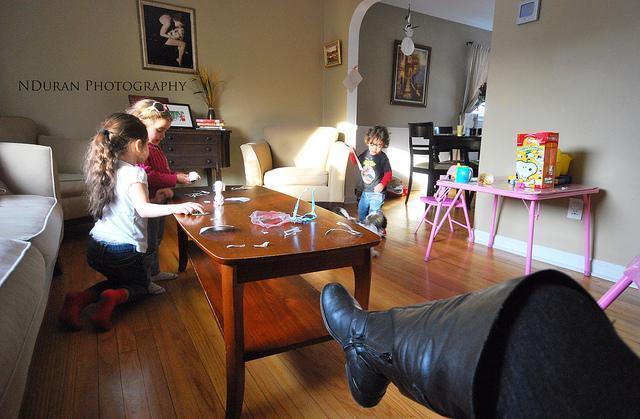How many people in the image are adult?
Give a very brief answer. 1. How many people are there?
Give a very brief answer. 4. How many chairs are there?
Give a very brief answer. 2. How many dining tables are there?
Give a very brief answer. 2. How many ears does the giraffe have?
Give a very brief answer. 0. 